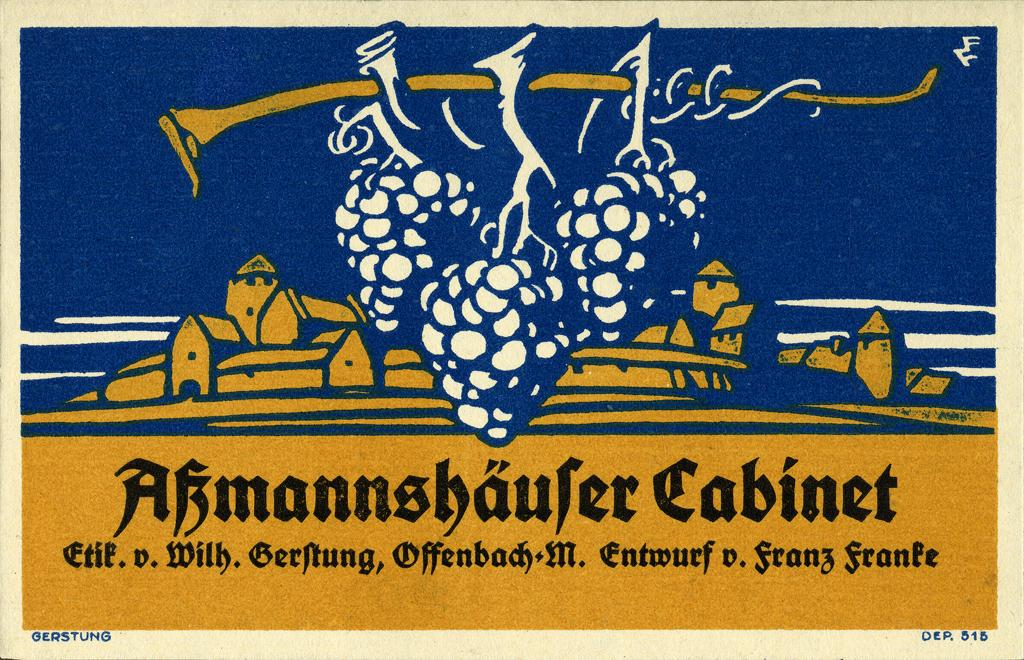<image>
Give a short and clear explanation of the subsequent image. A poster has the name Gerstung on it in tiny letters in the lower left corner. 